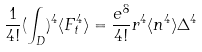Convert formula to latex. <formula><loc_0><loc_0><loc_500><loc_500>\frac { 1 } { 4 ! } ( \int _ { D } ) ^ { 4 } \langle F _ { t } ^ { 4 } \rangle = \frac { e ^ { 8 } } { 4 ! } r ^ { 4 } \langle n ^ { 4 } \rangle \Delta ^ { 4 }</formula> 